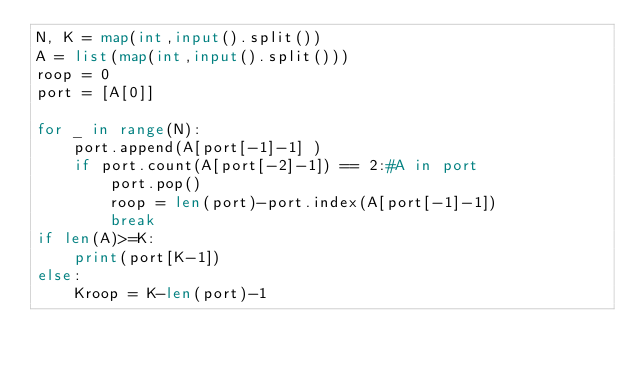<code> <loc_0><loc_0><loc_500><loc_500><_Python_>N, K = map(int,input().split())
A = list(map(int,input().split()))
roop = 0
port = [A[0]]
 
for _ in range(N):
    port.append(A[port[-1]-1] )
    if port.count(A[port[-2]-1]) == 2:#A in port
        port.pop()
        roop = len(port)-port.index(A[port[-1]-1])
        break
if len(A)>=K:
    print(port[K-1])
else:
    Kroop = K-len(port)-1</code> 